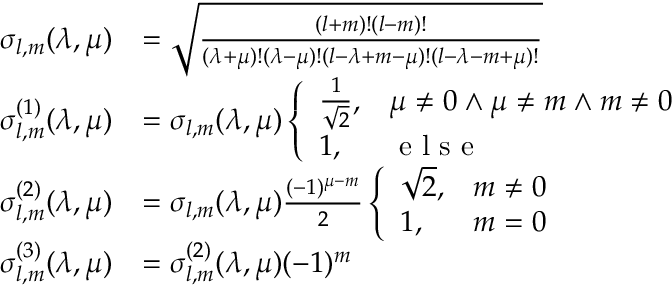Convert formula to latex. <formula><loc_0><loc_0><loc_500><loc_500>\begin{array} { r l } { \sigma _ { l , m } ( \lambda , \mu ) } & { = \sqrt { \frac { ( l + m ) ! ( l - m ) ! } { ( \lambda + \mu ) ! ( \lambda - \mu ) ! ( l - \lambda + m - \mu ) ! ( l - \lambda - m + \mu ) ! } } } \\ { \sigma _ { l , m } ^ { ( 1 ) } ( \lambda , \mu ) } & { = \sigma _ { l , m } ( \lambda , \mu ) \left \{ \begin{array} { l l } { \frac { 1 } { \sqrt { 2 } } , } & { \mu \neq 0 \land \mu \neq m \land m \neq 0 } \\ { 1 , } & { e l s e } \end{array} } \\ { \sigma _ { l , m } ^ { ( 2 ) } ( \lambda , \mu ) } & { = \sigma _ { l , m } ( \lambda , \mu ) \frac { ( - 1 ) ^ { \mu - m } } { 2 } \left \{ \begin{array} { l l } { \sqrt { 2 } , } & { m \neq 0 } \\ { 1 , } & { m = 0 } \end{array} } \\ { \sigma _ { l , m } ^ { ( 3 ) } ( \lambda , \mu ) } & { = \sigma _ { l , m } ^ { ( 2 ) } ( \lambda , \mu ) ( - 1 ) ^ { m } } \end{array}</formula> 